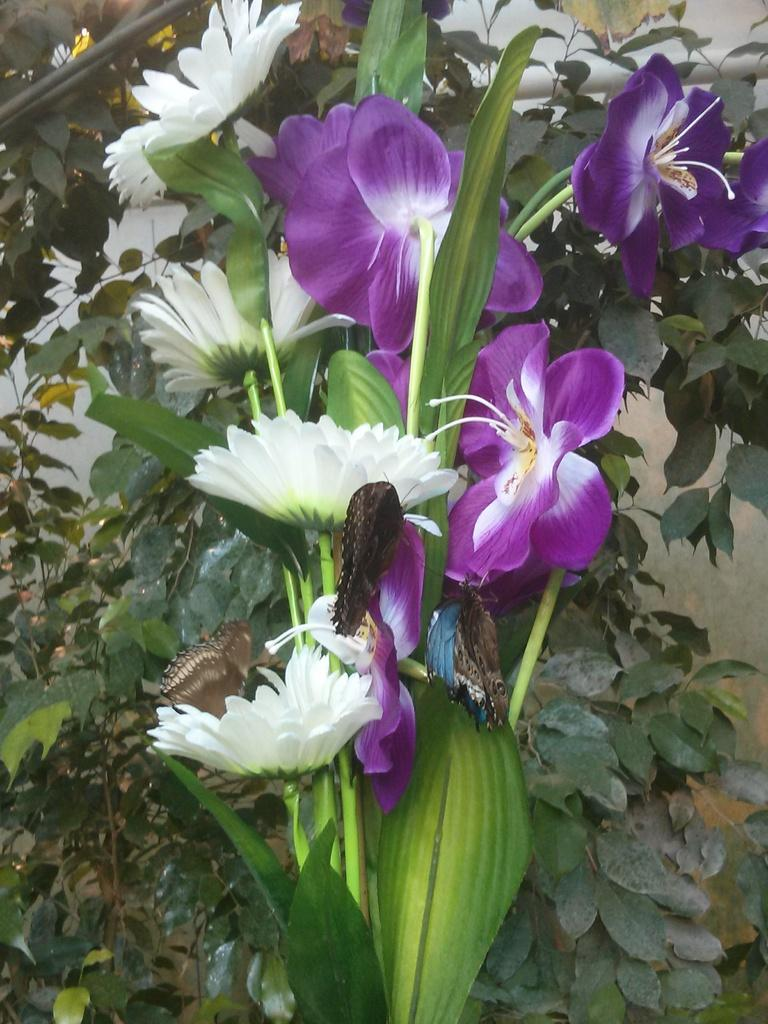What type of plants are present in the image? There are plants with flowers in the image. What can be seen on the flowers? There are butterflies on the flowers. What is visible behind the plants? There is a wall visible behind the plants. Where is the nest of the butterflies in the image? There is no nest present in the image; only butterflies on the flowers are visible. 